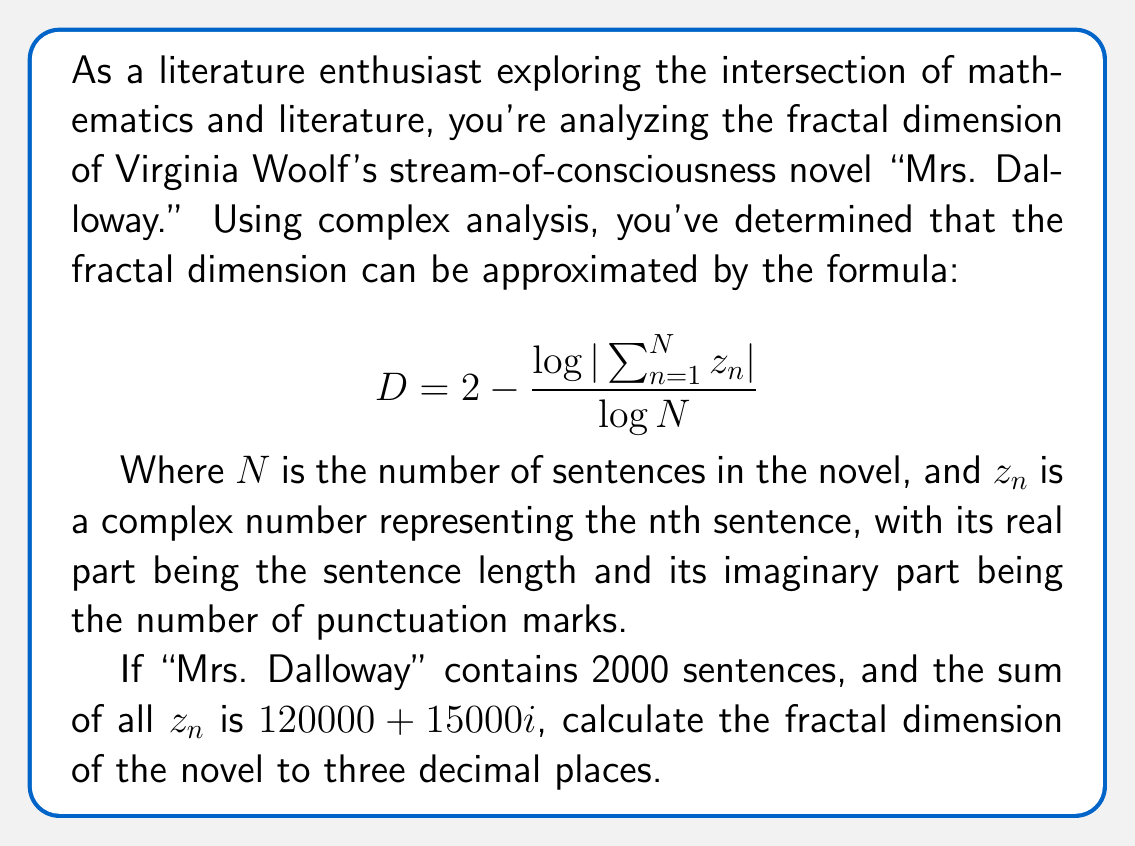Teach me how to tackle this problem. To solve this problem, we'll follow these steps:

1) We're given the formula for the fractal dimension D:
   $$D = 2 - \frac{\log|\sum_{n=1}^{N} z_n|}{\log N}$$

2) We know that:
   - $N = 2000$ (number of sentences)
   - $\sum_{n=1}^{N} z_n = 120000 + 15000i$

3) First, we need to calculate $|\sum_{n=1}^{N} z_n|$:
   $$|\sum_{n=1}^{N} z_n| = |120000 + 15000i| = \sqrt{120000^2 + 15000^2} = \sqrt{14625000000} = 120900$$

4) Now we can plug this value and $N$ into our formula:
   $$D = 2 - \frac{\log(120900)}{\log(2000)}$$

5) Let's calculate this step by step:
   $$\log(120900) \approx 11.7024$$
   $$\log(2000) \approx 7.6009$$

   $$D = 2 - \frac{11.7024}{7.6009} \approx 2 - 1.5396 \approx 0.4604$$

6) Rounding to three decimal places, we get 0.460.

This fractal dimension suggests that the structure of "Mrs. Dalloway" exhibits fractal-like properties, with a dimension between that of a line (1) and a plane (2), indicating a complex, self-similar structure in the novel's composition.
Answer: 0.460 